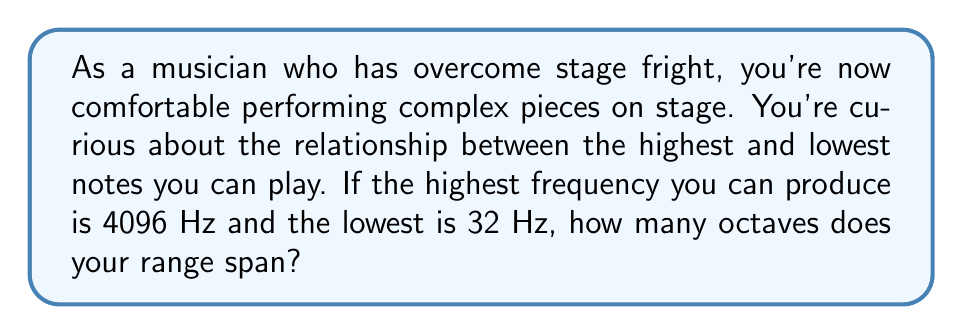Give your solution to this math problem. Let's approach this step-by-step:

1) An octave is defined as a doubling of frequency. So, to find the number of octaves, we need to determine how many times we need to double the lower frequency to reach the higher frequency.

2) We can express this mathematically as:
   $32 \cdot 2^n = 4096$, where $n$ is the number of octaves.

3) To solve this, we can use logarithms. Taking the log base 2 of both sides:
   $\log_2(32 \cdot 2^n) = \log_2(4096)$

4) Using the logarithm property $\log_a(x \cdot y) = \log_a(x) + \log_a(y)$:
   $\log_2(32) + \log_2(2^n) = \log_2(4096)$

5) Simplify $\log_2(2^n) = n$:
   $\log_2(32) + n = \log_2(4096)$

6) Solve for $n$:
   $n = \log_2(4096) - \log_2(32)$

7) We can simplify this further:
   $n = \log_2(\frac{4096}{32}) = \log_2(128) = 7$

Therefore, your range spans 7 octaves.
Answer: 7 octaves 